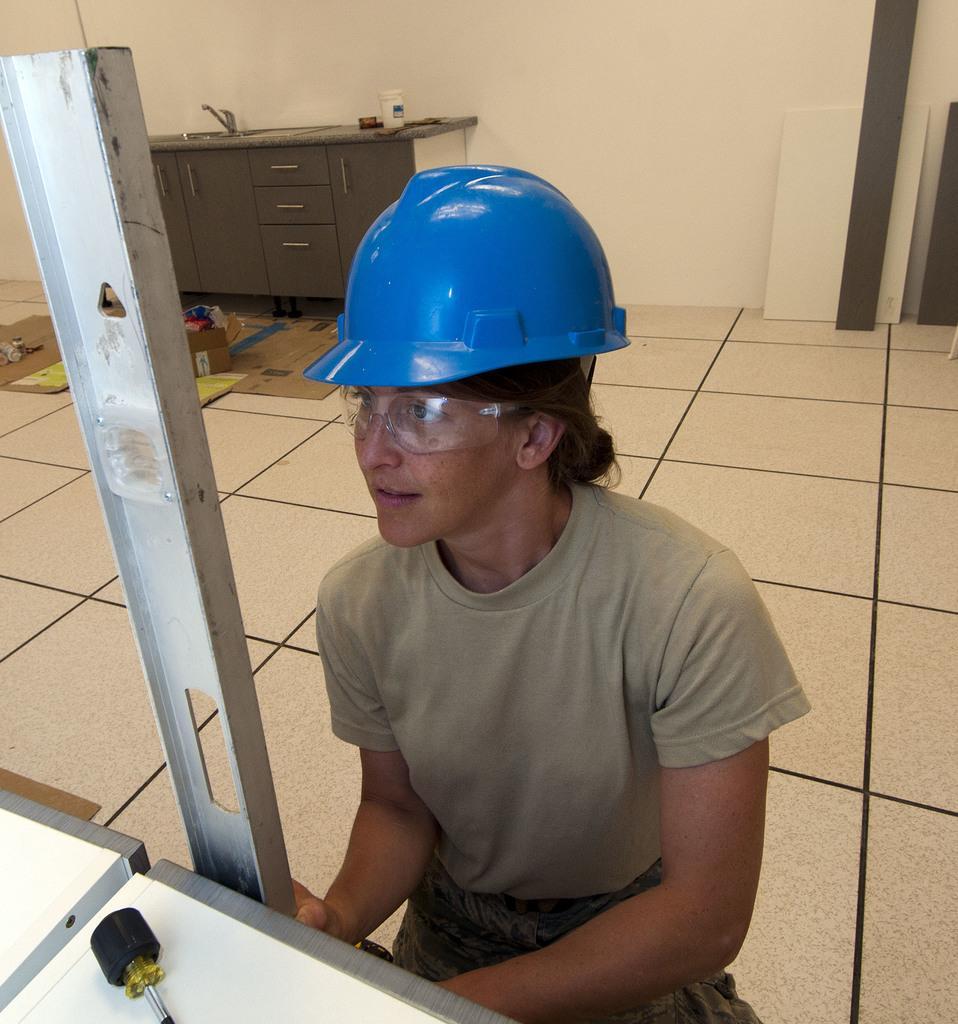In one or two sentences, can you explain what this image depicts? In the middle of the image we can see a woman, she is sitting, in front of her we can see a metal rod and an object on the table, in the background we can see cardboard, a tap and a bottle on the countertop. 